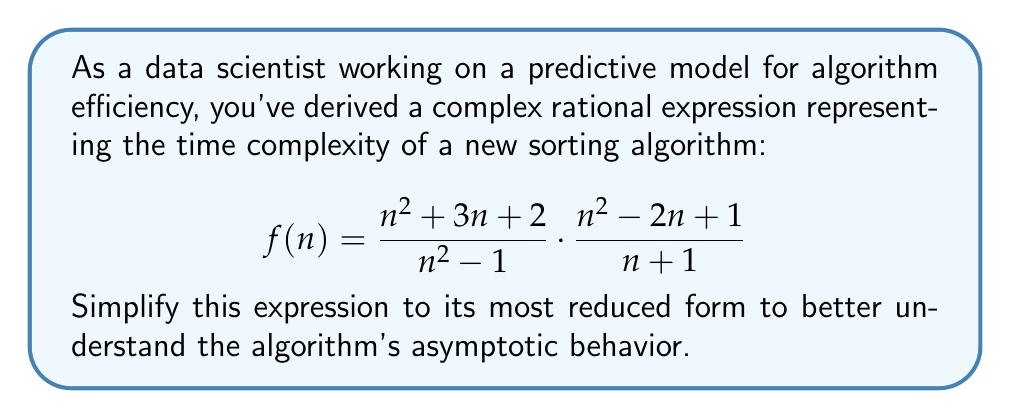Show me your answer to this math problem. Let's simplify this complex rational expression step by step:

1) First, let's multiply the numerators and denominators separately:

   $$f(n) = \frac{(n^2 + 3n + 2)(n^2 - 2n + 1)}{(n^2 - 1)(n + 1)}$$

2) Expand the numerator:
   $(n^2 + 3n + 2)(n^2 - 2n + 1)$
   $= n^4 - 2n^3 + n^2 + 3n^3 - 6n^2 + 3n + 2n^2 - 4n + 2$
   $= n^4 + n^3 - 3n^2 - n + 2$

3) The denominator can be factored:
   $(n^2 - 1)(n + 1) = (n-1)(n+1)(n+1) = (n-1)(n+1)^2$

4) Now our expression looks like:

   $$f(n) = \frac{n^4 + n^3 - 3n^2 - n + 2}{(n-1)(n+1)^2}$$

5) We can factor out $(n-1)$ from the numerator:
   $n^4 + n^3 - 3n^2 - n + 2$
   $= (n-1)(n^3 + 2n^2 - n - 2)$

6) Our expression becomes:

   $$f(n) = \frac{(n-1)(n^3 + 2n^2 - n - 2)}{(n-1)(n+1)^2}$$

7) The $(n-1)$ terms cancel out:

   $$f(n) = \frac{n^3 + 2n^2 - n - 2}{(n+1)^2}$$

8) This is the most reduced form of the expression.
Answer: $$\frac{n^3 + 2n^2 - n - 2}{(n+1)^2}$$ 